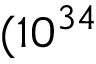Convert formula to latex. <formula><loc_0><loc_0><loc_500><loc_500>( 1 0 ^ { 3 4 }</formula> 